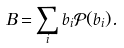Convert formula to latex. <formula><loc_0><loc_0><loc_500><loc_500>B = \sum _ { i } b _ { i } \mathcal { P } ( b _ { i } ) .</formula> 